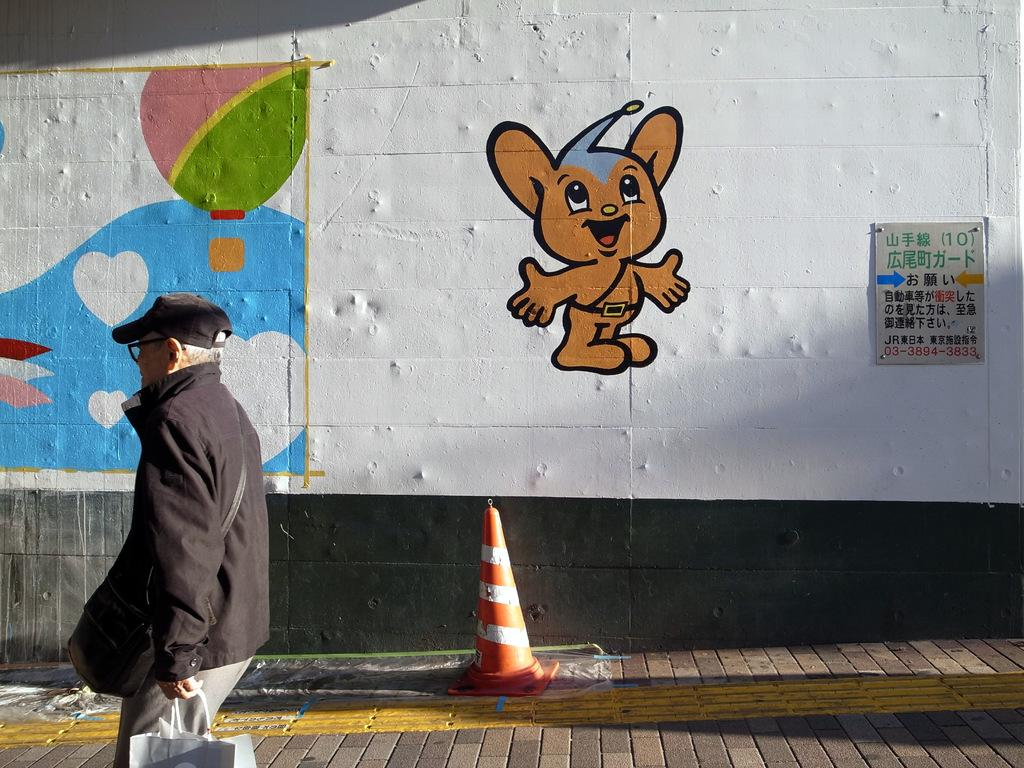What is the man in the image doing? The man is standing in the image and holding a bag. What object can be seen near the man? There is a cone barricade in the image. What can be seen in the background of the image? There are paintings and a board on the wall in the background of the image. What type of riddle is the man trying to solve in the image? There is no riddle present in the image; the man is simply standing and holding a bag. Can you tell me how many lawyers are visible in the image? There are no lawyers present in the image. 